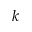Convert formula to latex. <formula><loc_0><loc_0><loc_500><loc_500>k</formula> 